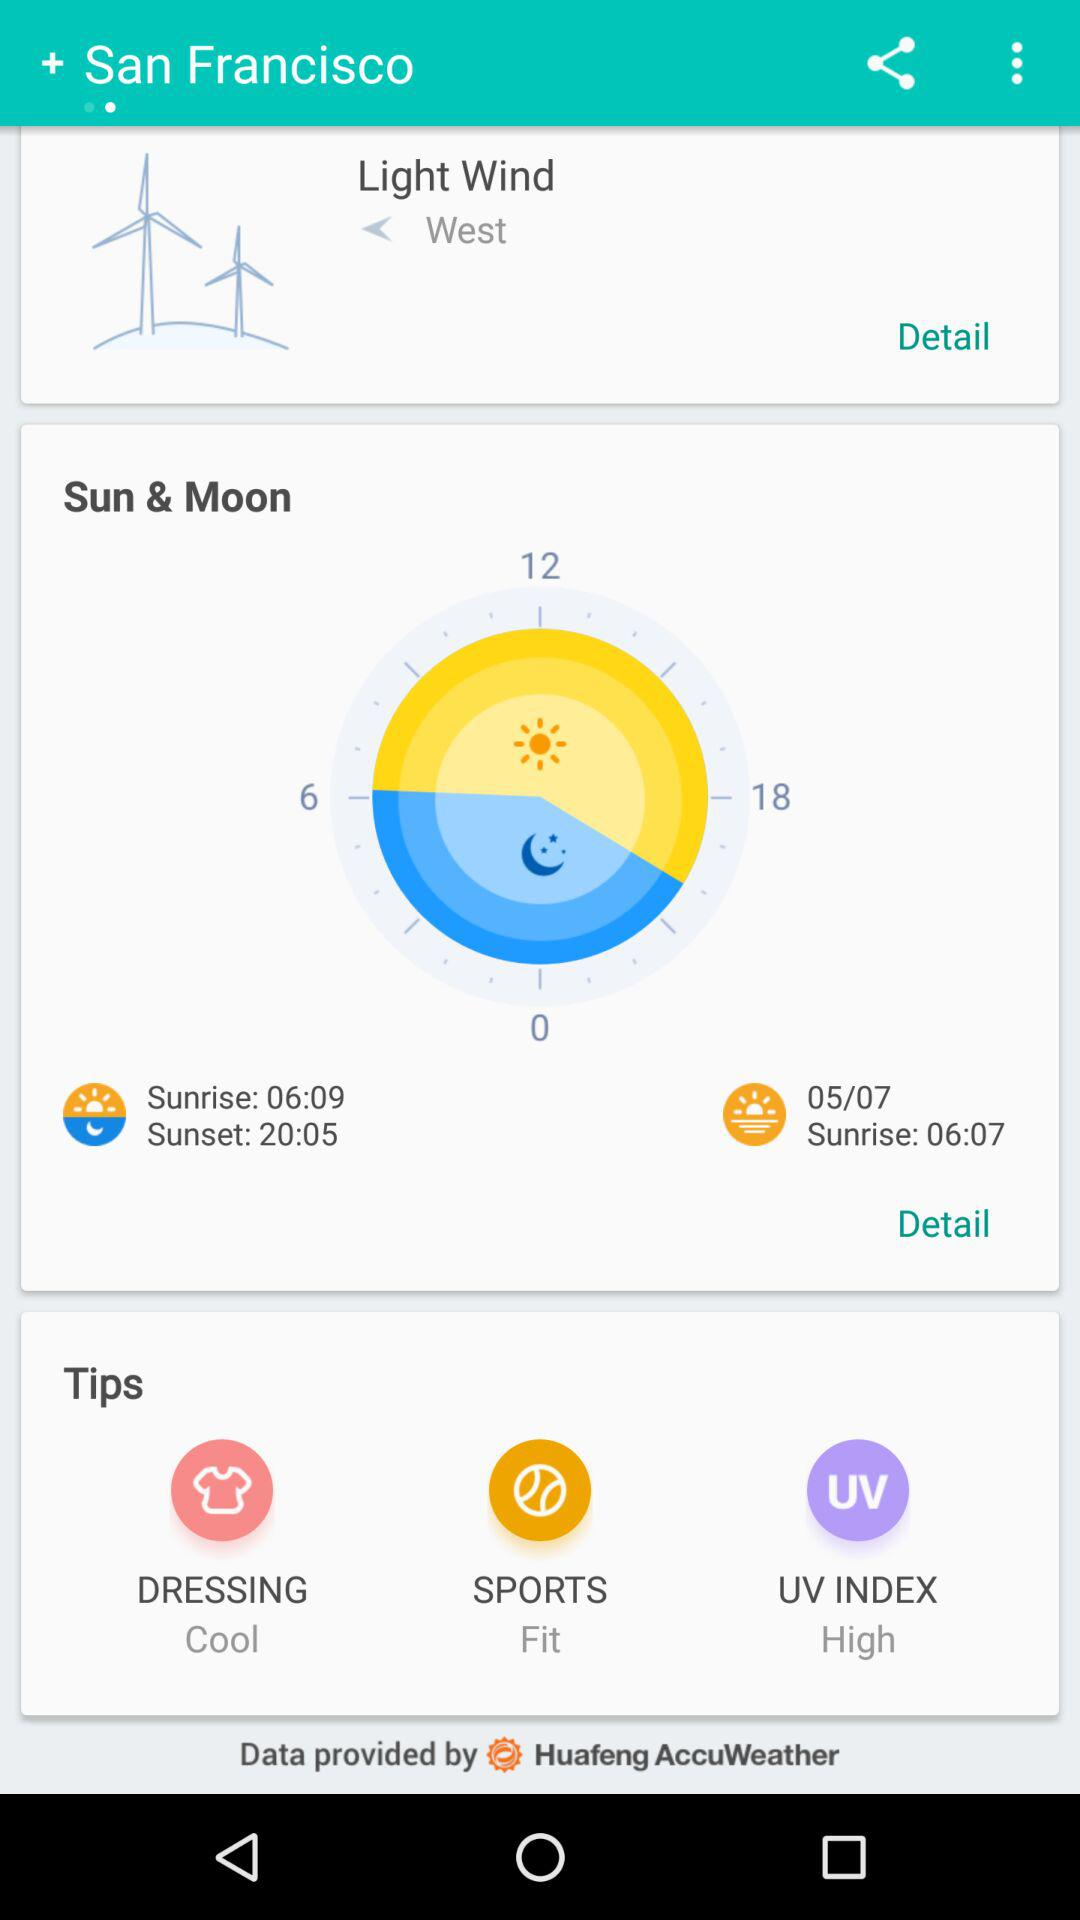How many hours are there between sunrise and sunset?
Answer the question using a single word or phrase. 14 